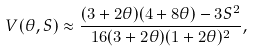Convert formula to latex. <formula><loc_0><loc_0><loc_500><loc_500>V ( \theta , S ) \approx \frac { ( 3 + 2 \theta ) ( 4 + 8 \theta ) - 3 S ^ { 2 } } { 1 6 ( 3 + 2 \theta ) ( 1 + 2 \theta ) ^ { 2 } } ,</formula> 